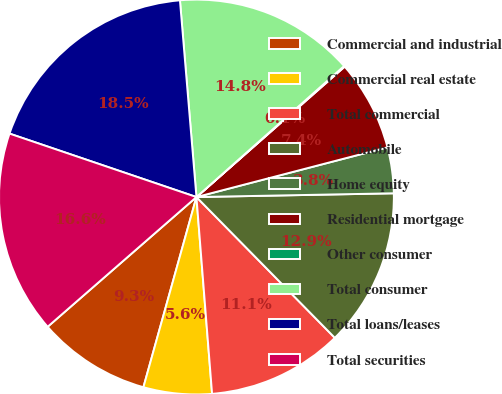Convert chart. <chart><loc_0><loc_0><loc_500><loc_500><pie_chart><fcel>Commercial and industrial<fcel>Commercial real estate<fcel>Total commercial<fcel>Automobile<fcel>Home equity<fcel>Residential mortgage<fcel>Other consumer<fcel>Total consumer<fcel>Total loans/leases<fcel>Total securities<nl><fcel>9.26%<fcel>5.59%<fcel>11.1%<fcel>12.94%<fcel>3.75%<fcel>7.43%<fcel>0.07%<fcel>14.78%<fcel>18.46%<fcel>16.62%<nl></chart> 